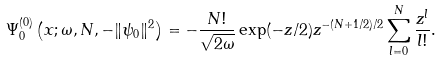Convert formula to latex. <formula><loc_0><loc_0><loc_500><loc_500>\Psi _ { 0 } ^ { ( 0 ) } \left ( x ; \omega , N , - \| \psi _ { 0 } \| ^ { 2 } \right ) = - \frac { N ! } { \sqrt { 2 \omega } } \exp ( - z / 2 ) z ^ { - ( N + 1 / 2 ) / 2 } \sum _ { l = 0 } ^ { N } \frac { z ^ { l } } { l ! } .</formula> 